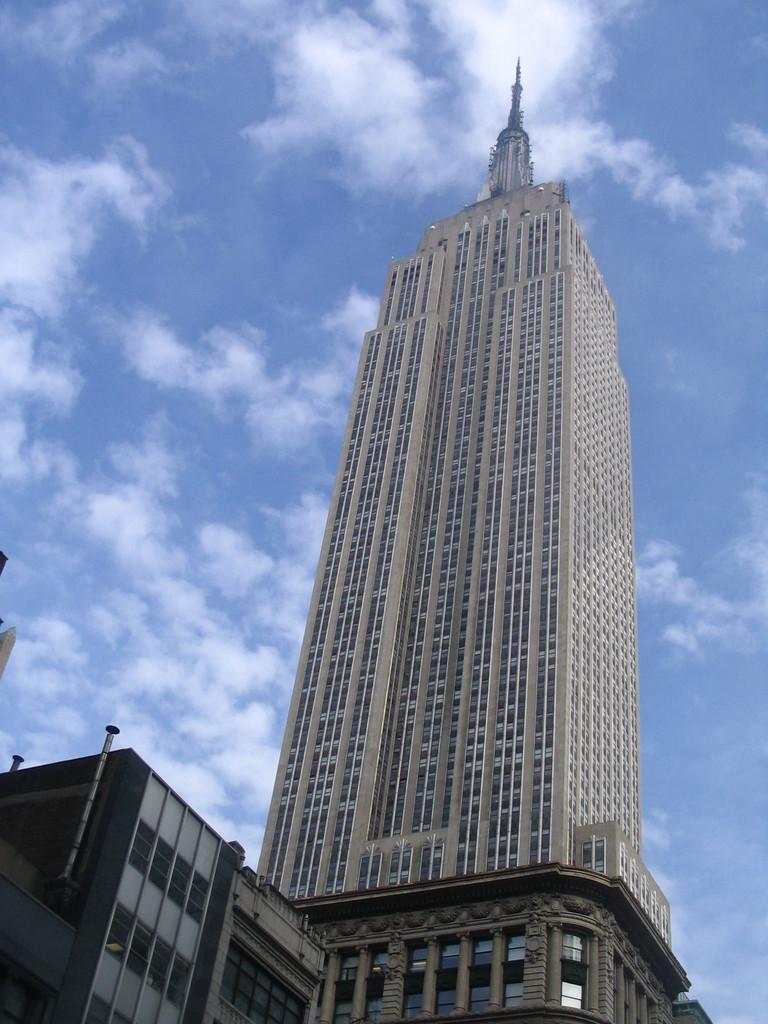What type of structure is present in the image? There is a building in the image. What other feature can be seen in the image? There is a tower in the image. What part of the natural environment is visible in the image? The sky is visible in the image. How would you describe the weather based on the sky in the image? The sky appears cloudy in the image. Where is the zipper located on the building in the image? There is no zipper present on the building in the image. What type of amusement can be seen in the image? There is no amusement depicted in the image; it features a building and a tower. 